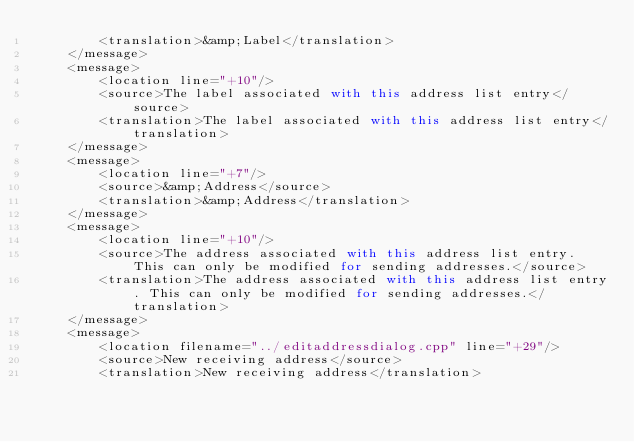<code> <loc_0><loc_0><loc_500><loc_500><_TypeScript_>        <translation>&amp;Label</translation>
    </message>
    <message>
        <location line="+10"/>
        <source>The label associated with this address list entry</source>
        <translation>The label associated with this address list entry</translation>
    </message>
    <message>
        <location line="+7"/>
        <source>&amp;Address</source>
        <translation>&amp;Address</translation>
    </message>
    <message>
        <location line="+10"/>
        <source>The address associated with this address list entry. This can only be modified for sending addresses.</source>
        <translation>The address associated with this address list entry. This can only be modified for sending addresses.</translation>
    </message>
    <message>
        <location filename="../editaddressdialog.cpp" line="+29"/>
        <source>New receiving address</source>
        <translation>New receiving address</translation></code> 